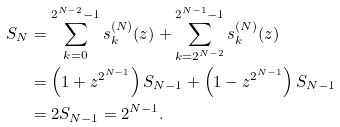<formula> <loc_0><loc_0><loc_500><loc_500>S _ { N } & = \sum _ { k = 0 } ^ { 2 ^ { N - 2 } - 1 } s _ { k } ^ { ( N ) } ( z ) + \sum _ { k = 2 ^ { N - 2 } } ^ { 2 ^ { N - 1 } - 1 } s _ { k } ^ { ( N ) } ( z ) \\ & = \left ( 1 + z ^ { 2 ^ { N - 1 } } \right ) S _ { N - 1 } + \left ( 1 - z ^ { 2 ^ { N - 1 } } \right ) S _ { N - 1 } \\ & = 2 S _ { N - 1 } = 2 ^ { N - 1 } .</formula> 